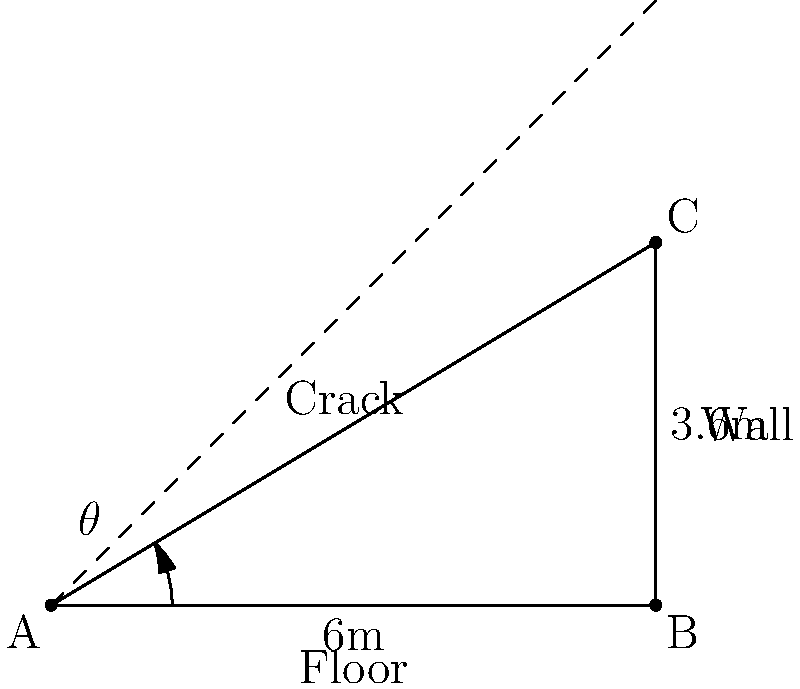A crack has been observed in a foundation wall, running from the floor to a point 3.6 meters up the wall, spanning a horizontal distance of 6 meters. What is the angle $\theta$ of the crack with respect to the horizontal, and what does this angle suggest about the potential cause and severity of the structural issue? To solve this problem, we'll follow these steps:

1) First, we need to determine the angle of the crack. We can do this using the arctangent function, as we have the opposite and adjacent sides of a right triangle.

2) The opposite side (vertical height) is 3.6 meters, and the adjacent side (horizontal distance) is 6 meters.

3) Using the arctangent function:

   $\theta = \arctan(\frac{\text{opposite}}{\text{adjacent}}) = \arctan(\frac{3.6}{6})$

4) Calculate this value:
   
   $\theta = \arctan(0.6) \approx 30.96°$

5) Interpreting this angle:
   - A 30.96° angle is relatively steep for a foundation crack.
   - Cracks at angles greater than 30° often indicate differential settlement, where one part of the foundation is sinking more rapidly than another.
   - This type of settlement can be caused by various factors such as soil consolidation, poor drainage, or nearby excavation.

6) Severity assessment:
   - The steepness and length of the crack (over 7 meters along the crack) suggest a significant structural issue.
   - This type of crack can compromise the wall's load-bearing capacity and may allow water infiltration.
   - Immediate professional assessment and intervention are likely necessary to prevent further damage and ensure structural integrity.
Answer: $30.96°$; indicates severe differential settlement requiring immediate professional intervention. 